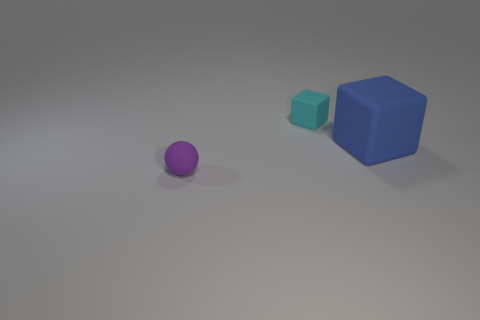Is there any other thing that has the same shape as the big blue rubber thing?
Keep it short and to the point. Yes. The other large thing that is the same shape as the cyan object is what color?
Give a very brief answer. Blue. There is a big object that is the same material as the sphere; what is its color?
Keep it short and to the point. Blue. Are there the same number of small cyan things that are on the right side of the large blue object and metallic balls?
Your answer should be compact. Yes. Is the size of the object that is left of the cyan rubber cube the same as the large blue thing?
Your response must be concise. No. What is the color of the cube that is the same size as the purple matte object?
Offer a very short reply. Cyan. There is a matte thing on the right side of the tiny rubber thing that is behind the purple rubber sphere; is there a blue object behind it?
Keep it short and to the point. No. There is a cube to the left of the large blue object; what material is it?
Give a very brief answer. Rubber. There is a cyan rubber object; is its shape the same as the big blue thing in front of the tiny cube?
Keep it short and to the point. Yes. Are there an equal number of large objects to the left of the tiny cyan cube and cubes left of the large blue matte thing?
Give a very brief answer. No. 